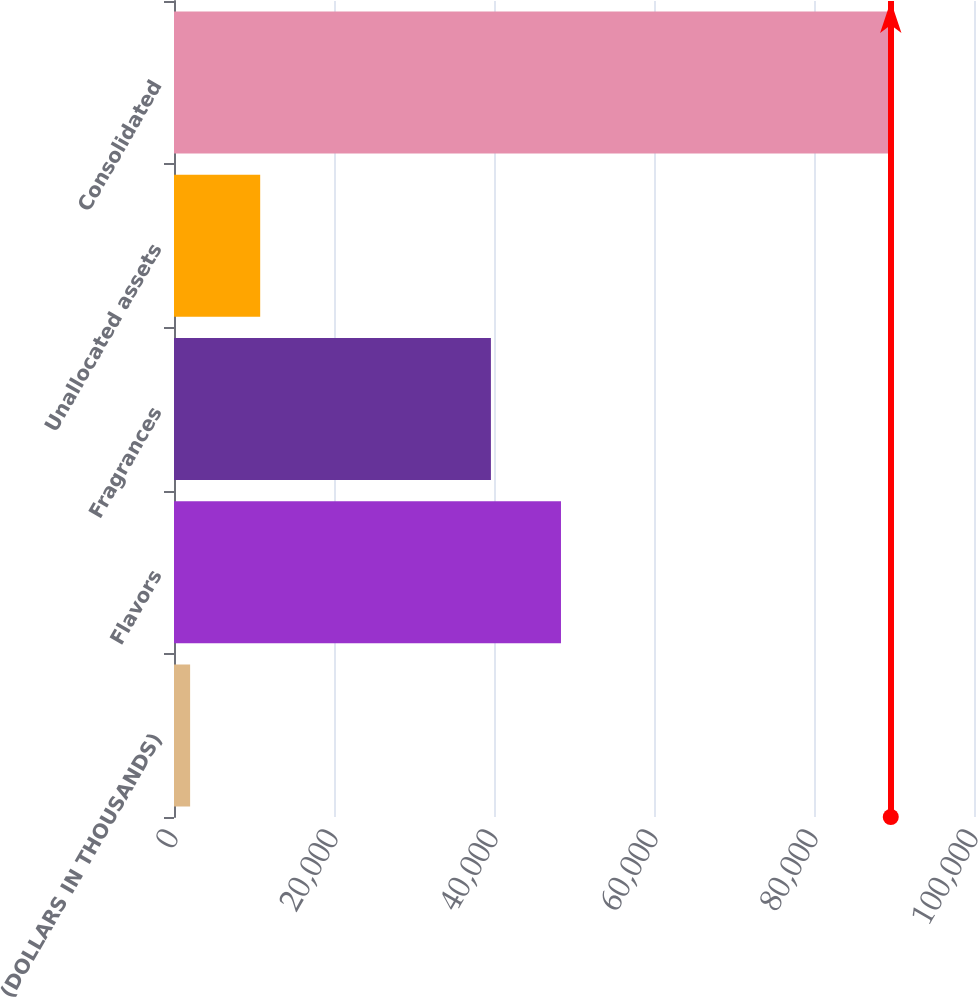Convert chart. <chart><loc_0><loc_0><loc_500><loc_500><bar_chart><fcel>(DOLLARS IN THOUSANDS)<fcel>Flavors<fcel>Fragrances<fcel>Unallocated assets<fcel>Consolidated<nl><fcel>2015<fcel>48372.2<fcel>39614<fcel>10773.2<fcel>89597<nl></chart> 